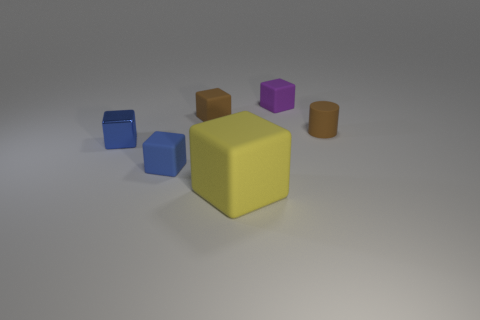What color is the cylinder that is the same size as the blue metallic thing?
Provide a short and direct response. Brown. What number of things are tiny brown rubber things that are to the right of the big rubber block or small objects to the left of the yellow object?
Keep it short and to the point. 4. Is the number of rubber cylinders that are right of the yellow block the same as the number of small purple rubber objects?
Your answer should be very brief. Yes. Does the brown thing to the left of the tiny matte cylinder have the same size as the matte object that is to the right of the purple object?
Provide a succinct answer. Yes. What number of other objects are the same size as the metal block?
Keep it short and to the point. 4. There is a matte object that is on the right side of the small block that is right of the small brown matte cube; are there any tiny brown things on the left side of it?
Provide a short and direct response. Yes. Are there any other things that are the same color as the tiny metallic thing?
Offer a terse response. Yes. How big is the brown thing behind the small matte cylinder?
Your answer should be compact. Small. What is the size of the block in front of the blue block that is in front of the shiny cube that is in front of the small purple thing?
Your answer should be compact. Large. There is a matte cube that is on the right side of the big yellow matte thing that is in front of the small brown rubber cylinder; what color is it?
Provide a succinct answer. Purple. 